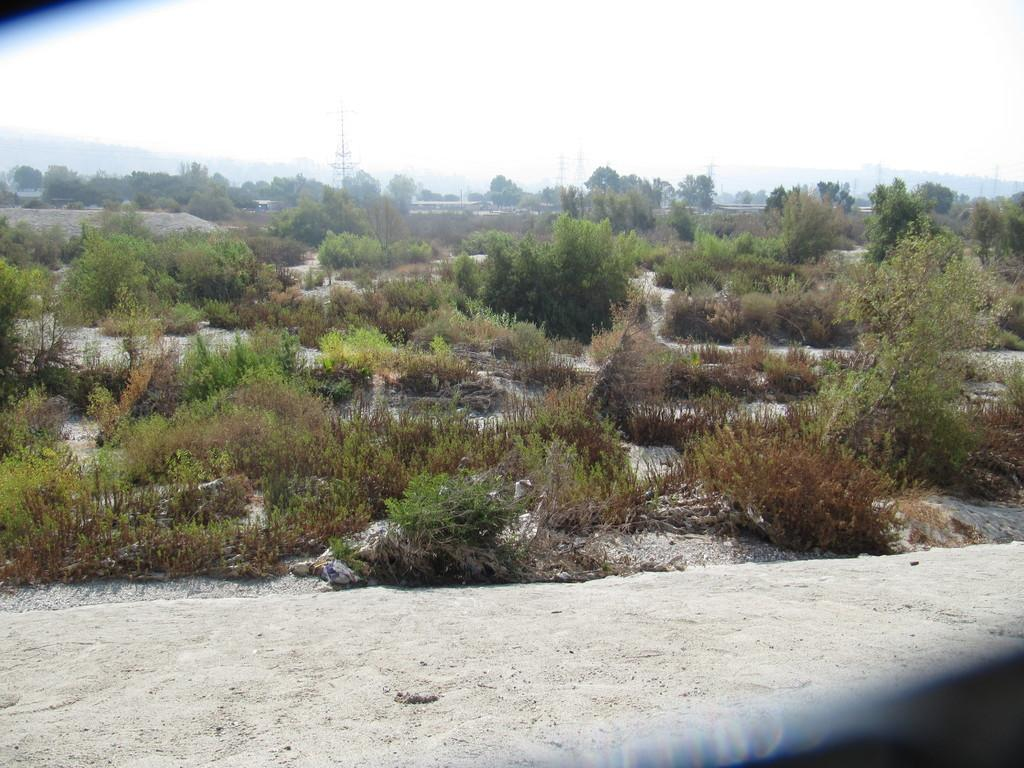What type of vegetation can be seen in the image? There are plants and trees in the image. What is visible at the top of the image? The sky is visible at the top of the image. What type of hair can be seen on the plants in the image? There is no hair present on the plants in the image. What type of attraction can be seen in the image? There is no attraction present in the image; it features plants, trees, and the sky. 